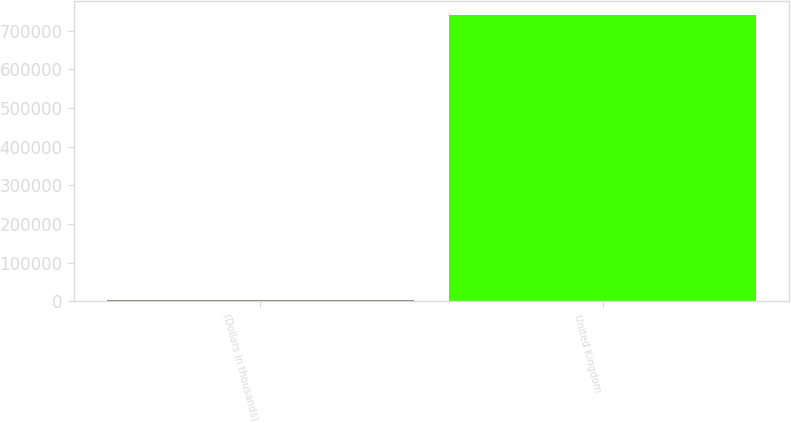<chart> <loc_0><loc_0><loc_500><loc_500><bar_chart><fcel>(Dollars in thousands)<fcel>United Kingdom<nl><fcel>2015<fcel>740763<nl></chart> 